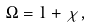Convert formula to latex. <formula><loc_0><loc_0><loc_500><loc_500>\Omega = 1 + \chi ,</formula> 